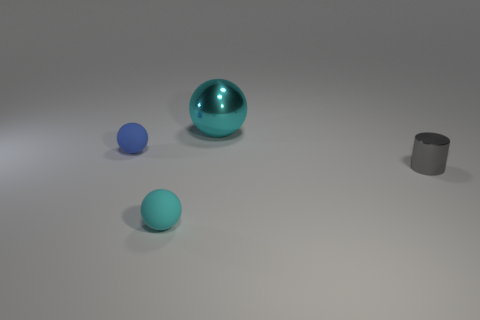Is the size of the shiny ball the same as the matte thing that is in front of the blue object?
Keep it short and to the point. No. There is a gray metal object in front of the large metal ball; are there any tiny metal things behind it?
Make the answer very short. No. There is a ball that is both behind the small gray cylinder and in front of the cyan shiny thing; what is its material?
Ensure brevity in your answer.  Rubber. What color is the metal object that is on the right side of the cyan thing that is behind the shiny object in front of the big cyan shiny sphere?
Give a very brief answer. Gray. What is the color of the sphere that is the same size as the blue rubber object?
Keep it short and to the point. Cyan. Do the shiny cylinder and the small object that is behind the tiny gray cylinder have the same color?
Offer a very short reply. No. What is the material of the small thing on the left side of the small matte thing in front of the small gray shiny thing?
Your response must be concise. Rubber. How many things are to the right of the small cyan matte thing and to the left of the small gray thing?
Your response must be concise. 1. How many other things are the same size as the gray cylinder?
Give a very brief answer. 2. There is a rubber thing to the right of the blue sphere; is it the same shape as the cyan thing that is behind the tiny metal thing?
Keep it short and to the point. Yes. 